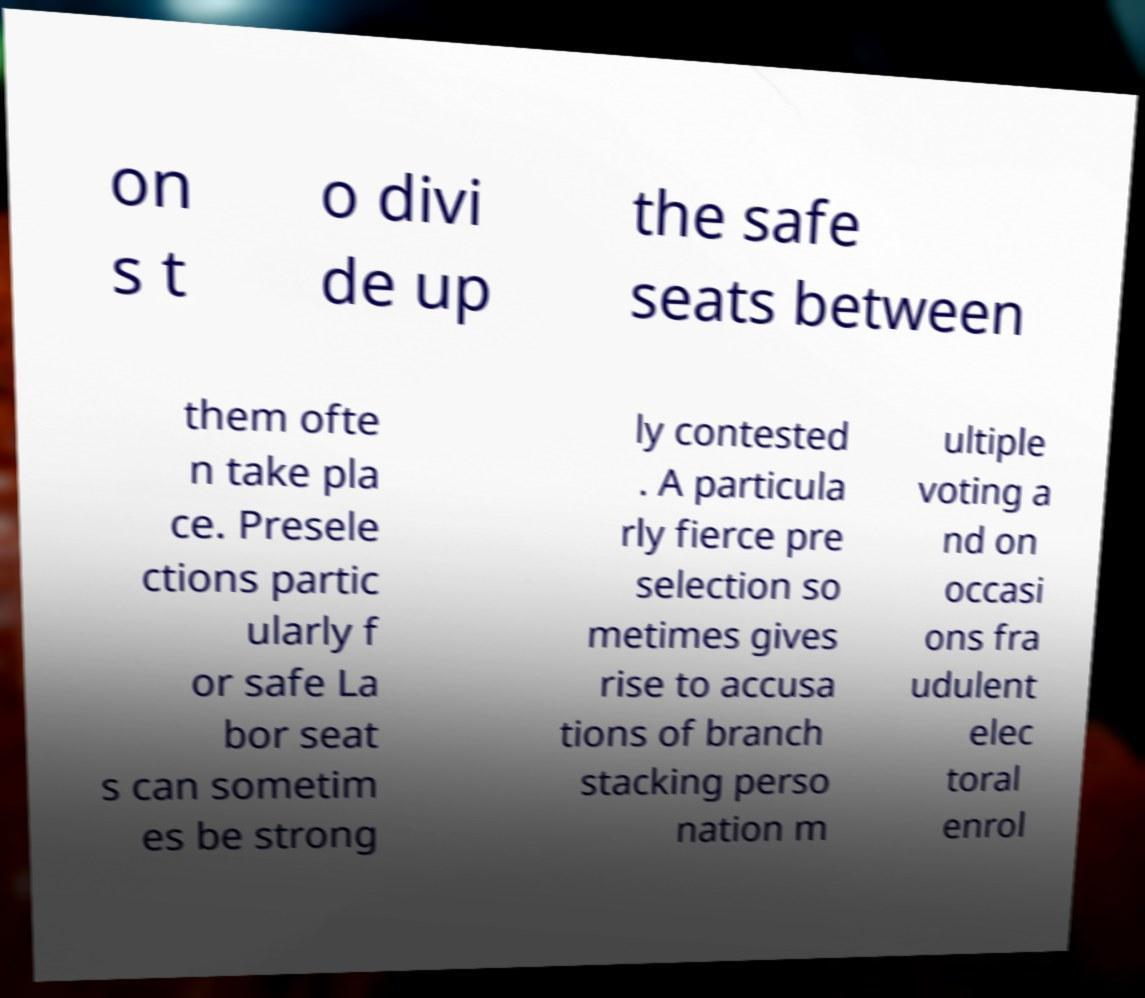What messages or text are displayed in this image? I need them in a readable, typed format. on s t o divi de up the safe seats between them ofte n take pla ce. Presele ctions partic ularly f or safe La bor seat s can sometim es be strong ly contested . A particula rly fierce pre selection so metimes gives rise to accusa tions of branch stacking perso nation m ultiple voting a nd on occasi ons fra udulent elec toral enrol 